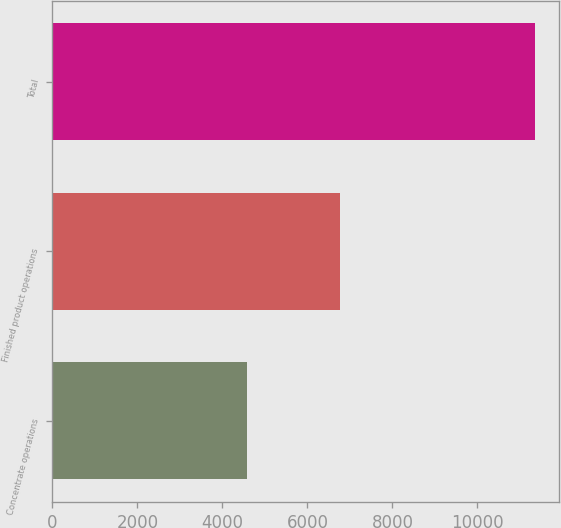<chart> <loc_0><loc_0><loc_500><loc_500><bar_chart><fcel>Concentrate operations<fcel>Finished product operations<fcel>Total<nl><fcel>4571<fcel>6773<fcel>11344<nl></chart> 